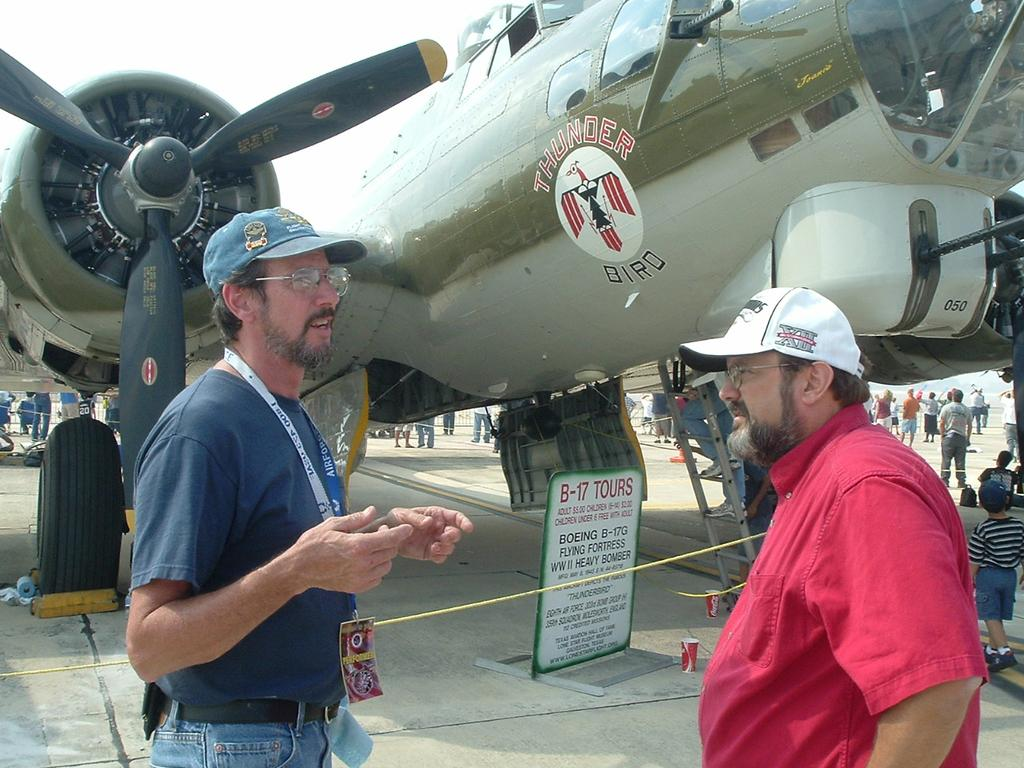<image>
Relay a brief, clear account of the picture shown. two men standing next to an airplane that says thunder bird 